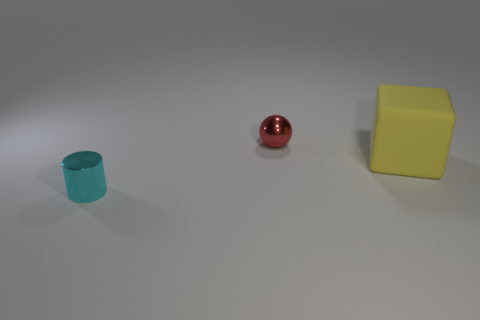What is the size relationship between these objects? From the perspective provided, the yellow cube appears to be the largest, followed by the cyan cylinder, and then the red sphere being the smallest. 